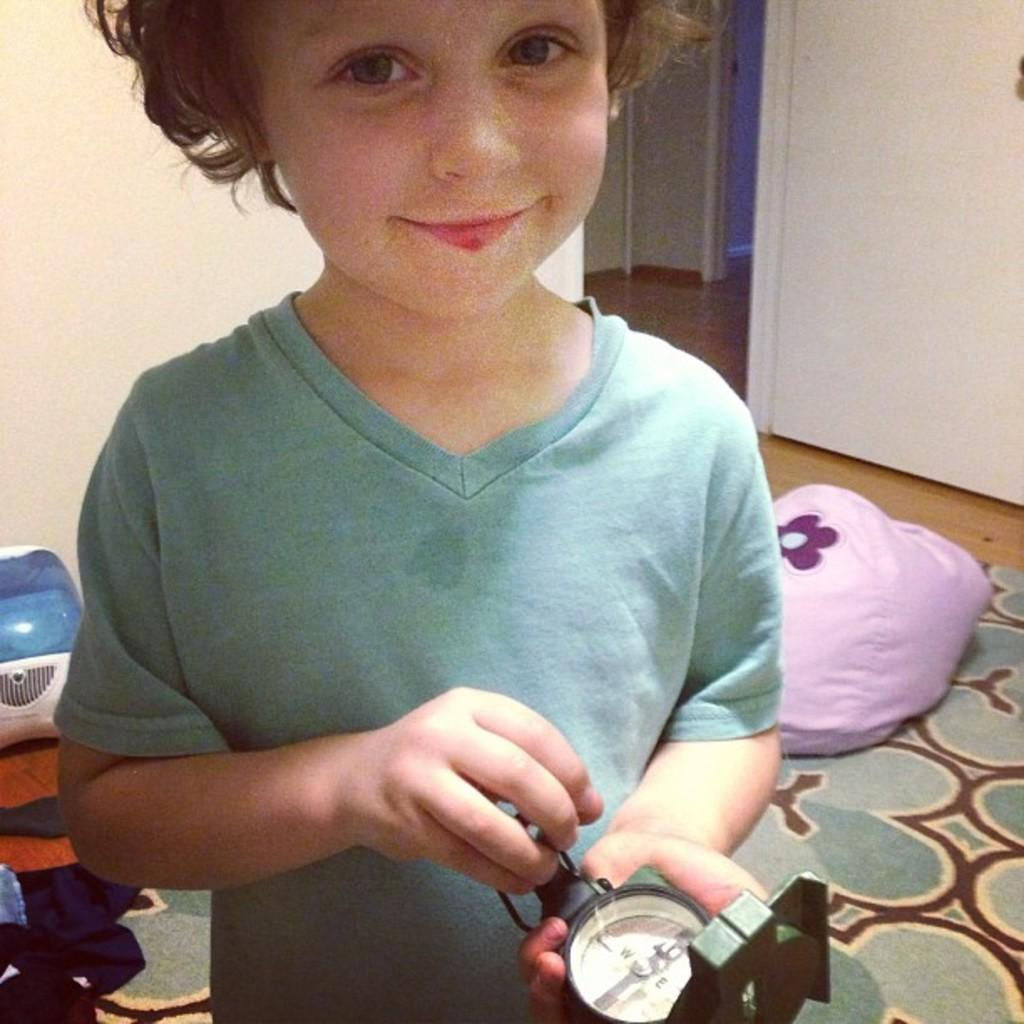What is the main subject of the image? There is a kid in the image. What is the kid doing in the image? The kid is holding an object and watching and smiling. What can be seen in the background of the image? There are walls, a door, a floor, and other objects in the background of the image. What type of chalk is the kid using to draw on the low ceiling in the image? There is no chalk or low ceiling present in the image. How many spoons are visible on the floor in the image? There are no spoons visible on the floor in the image. 